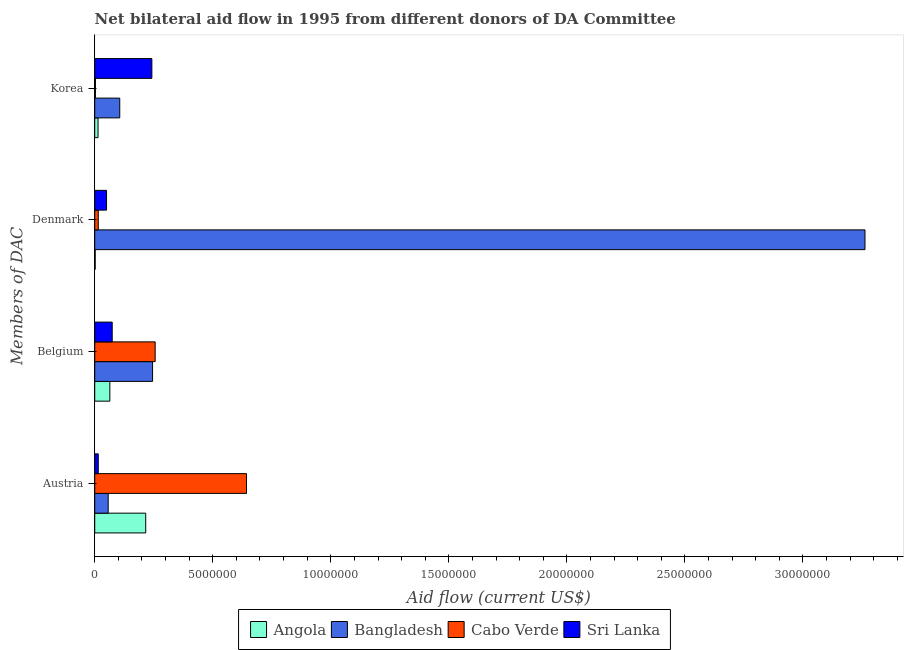How many different coloured bars are there?
Your answer should be compact. 4. Are the number of bars per tick equal to the number of legend labels?
Offer a terse response. Yes. Are the number of bars on each tick of the Y-axis equal?
Your answer should be compact. Yes. How many bars are there on the 1st tick from the bottom?
Make the answer very short. 4. What is the amount of aid given by korea in Bangladesh?
Provide a succinct answer. 1.06e+06. Across all countries, what is the maximum amount of aid given by denmark?
Your answer should be very brief. 3.26e+07. Across all countries, what is the minimum amount of aid given by austria?
Provide a succinct answer. 1.50e+05. In which country was the amount of aid given by korea maximum?
Provide a succinct answer. Sri Lanka. In which country was the amount of aid given by denmark minimum?
Your response must be concise. Angola. What is the total amount of aid given by belgium in the graph?
Give a very brief answer. 6.39e+06. What is the difference between the amount of aid given by belgium in Cabo Verde and that in Bangladesh?
Offer a terse response. 1.10e+05. What is the difference between the amount of aid given by korea in Sri Lanka and the amount of aid given by belgium in Cabo Verde?
Your response must be concise. -1.40e+05. What is the average amount of aid given by belgium per country?
Offer a terse response. 1.60e+06. What is the difference between the amount of aid given by korea and amount of aid given by austria in Angola?
Your answer should be compact. -2.02e+06. What is the ratio of the amount of aid given by denmark in Bangladesh to that in Angola?
Your response must be concise. 1631.5. Is the difference between the amount of aid given by austria in Cabo Verde and Bangladesh greater than the difference between the amount of aid given by denmark in Cabo Verde and Bangladesh?
Offer a terse response. Yes. What is the difference between the highest and the second highest amount of aid given by belgium?
Offer a terse response. 1.10e+05. What is the difference between the highest and the lowest amount of aid given by austria?
Give a very brief answer. 6.28e+06. In how many countries, is the amount of aid given by korea greater than the average amount of aid given by korea taken over all countries?
Offer a terse response. 2. Is the sum of the amount of aid given by austria in Angola and Sri Lanka greater than the maximum amount of aid given by korea across all countries?
Offer a very short reply. No. What does the 2nd bar from the bottom in Austria represents?
Give a very brief answer. Bangladesh. How many bars are there?
Your answer should be compact. 16. Are all the bars in the graph horizontal?
Make the answer very short. Yes. How many countries are there in the graph?
Offer a terse response. 4. Does the graph contain grids?
Your answer should be compact. No. Where does the legend appear in the graph?
Offer a terse response. Bottom center. What is the title of the graph?
Offer a terse response. Net bilateral aid flow in 1995 from different donors of DA Committee. Does "Vietnam" appear as one of the legend labels in the graph?
Offer a very short reply. No. What is the label or title of the Y-axis?
Offer a terse response. Members of DAC. What is the Aid flow (current US$) in Angola in Austria?
Your answer should be compact. 2.16e+06. What is the Aid flow (current US$) in Bangladesh in Austria?
Provide a short and direct response. 5.70e+05. What is the Aid flow (current US$) of Cabo Verde in Austria?
Provide a short and direct response. 6.43e+06. What is the Aid flow (current US$) of Sri Lanka in Austria?
Keep it short and to the point. 1.50e+05. What is the Aid flow (current US$) of Angola in Belgium?
Your answer should be very brief. 6.40e+05. What is the Aid flow (current US$) in Bangladesh in Belgium?
Make the answer very short. 2.45e+06. What is the Aid flow (current US$) of Cabo Verde in Belgium?
Give a very brief answer. 2.56e+06. What is the Aid flow (current US$) of Sri Lanka in Belgium?
Provide a short and direct response. 7.40e+05. What is the Aid flow (current US$) of Bangladesh in Denmark?
Your answer should be compact. 3.26e+07. What is the Aid flow (current US$) in Sri Lanka in Denmark?
Your answer should be very brief. 5.00e+05. What is the Aid flow (current US$) in Bangladesh in Korea?
Offer a very short reply. 1.06e+06. What is the Aid flow (current US$) of Cabo Verde in Korea?
Offer a terse response. 3.00e+04. What is the Aid flow (current US$) in Sri Lanka in Korea?
Your answer should be very brief. 2.42e+06. Across all Members of DAC, what is the maximum Aid flow (current US$) in Angola?
Your response must be concise. 2.16e+06. Across all Members of DAC, what is the maximum Aid flow (current US$) of Bangladesh?
Your answer should be very brief. 3.26e+07. Across all Members of DAC, what is the maximum Aid flow (current US$) of Cabo Verde?
Your answer should be very brief. 6.43e+06. Across all Members of DAC, what is the maximum Aid flow (current US$) in Sri Lanka?
Your answer should be compact. 2.42e+06. Across all Members of DAC, what is the minimum Aid flow (current US$) of Angola?
Provide a short and direct response. 2.00e+04. Across all Members of DAC, what is the minimum Aid flow (current US$) in Bangladesh?
Your answer should be compact. 5.70e+05. Across all Members of DAC, what is the minimum Aid flow (current US$) of Cabo Verde?
Provide a short and direct response. 3.00e+04. What is the total Aid flow (current US$) in Angola in the graph?
Provide a succinct answer. 2.96e+06. What is the total Aid flow (current US$) of Bangladesh in the graph?
Offer a terse response. 3.67e+07. What is the total Aid flow (current US$) in Cabo Verde in the graph?
Make the answer very short. 9.17e+06. What is the total Aid flow (current US$) in Sri Lanka in the graph?
Your answer should be very brief. 3.81e+06. What is the difference between the Aid flow (current US$) in Angola in Austria and that in Belgium?
Give a very brief answer. 1.52e+06. What is the difference between the Aid flow (current US$) in Bangladesh in Austria and that in Belgium?
Your answer should be very brief. -1.88e+06. What is the difference between the Aid flow (current US$) in Cabo Verde in Austria and that in Belgium?
Your answer should be compact. 3.87e+06. What is the difference between the Aid flow (current US$) of Sri Lanka in Austria and that in Belgium?
Provide a succinct answer. -5.90e+05. What is the difference between the Aid flow (current US$) in Angola in Austria and that in Denmark?
Your answer should be compact. 2.14e+06. What is the difference between the Aid flow (current US$) in Bangladesh in Austria and that in Denmark?
Give a very brief answer. -3.21e+07. What is the difference between the Aid flow (current US$) in Cabo Verde in Austria and that in Denmark?
Your answer should be compact. 6.28e+06. What is the difference between the Aid flow (current US$) of Sri Lanka in Austria and that in Denmark?
Your answer should be very brief. -3.50e+05. What is the difference between the Aid flow (current US$) of Angola in Austria and that in Korea?
Your answer should be very brief. 2.02e+06. What is the difference between the Aid flow (current US$) in Bangladesh in Austria and that in Korea?
Your answer should be very brief. -4.90e+05. What is the difference between the Aid flow (current US$) of Cabo Verde in Austria and that in Korea?
Your answer should be very brief. 6.40e+06. What is the difference between the Aid flow (current US$) of Sri Lanka in Austria and that in Korea?
Give a very brief answer. -2.27e+06. What is the difference between the Aid flow (current US$) of Angola in Belgium and that in Denmark?
Offer a very short reply. 6.20e+05. What is the difference between the Aid flow (current US$) of Bangladesh in Belgium and that in Denmark?
Offer a very short reply. -3.02e+07. What is the difference between the Aid flow (current US$) in Cabo Verde in Belgium and that in Denmark?
Give a very brief answer. 2.41e+06. What is the difference between the Aid flow (current US$) of Sri Lanka in Belgium and that in Denmark?
Your answer should be very brief. 2.40e+05. What is the difference between the Aid flow (current US$) in Angola in Belgium and that in Korea?
Your response must be concise. 5.00e+05. What is the difference between the Aid flow (current US$) in Bangladesh in Belgium and that in Korea?
Make the answer very short. 1.39e+06. What is the difference between the Aid flow (current US$) of Cabo Verde in Belgium and that in Korea?
Give a very brief answer. 2.53e+06. What is the difference between the Aid flow (current US$) of Sri Lanka in Belgium and that in Korea?
Your answer should be compact. -1.68e+06. What is the difference between the Aid flow (current US$) of Angola in Denmark and that in Korea?
Your answer should be compact. -1.20e+05. What is the difference between the Aid flow (current US$) in Bangladesh in Denmark and that in Korea?
Offer a terse response. 3.16e+07. What is the difference between the Aid flow (current US$) in Cabo Verde in Denmark and that in Korea?
Provide a short and direct response. 1.20e+05. What is the difference between the Aid flow (current US$) of Sri Lanka in Denmark and that in Korea?
Ensure brevity in your answer.  -1.92e+06. What is the difference between the Aid flow (current US$) in Angola in Austria and the Aid flow (current US$) in Bangladesh in Belgium?
Provide a short and direct response. -2.90e+05. What is the difference between the Aid flow (current US$) of Angola in Austria and the Aid flow (current US$) of Cabo Verde in Belgium?
Provide a short and direct response. -4.00e+05. What is the difference between the Aid flow (current US$) in Angola in Austria and the Aid flow (current US$) in Sri Lanka in Belgium?
Provide a succinct answer. 1.42e+06. What is the difference between the Aid flow (current US$) in Bangladesh in Austria and the Aid flow (current US$) in Cabo Verde in Belgium?
Ensure brevity in your answer.  -1.99e+06. What is the difference between the Aid flow (current US$) in Bangladesh in Austria and the Aid flow (current US$) in Sri Lanka in Belgium?
Keep it short and to the point. -1.70e+05. What is the difference between the Aid flow (current US$) of Cabo Verde in Austria and the Aid flow (current US$) of Sri Lanka in Belgium?
Give a very brief answer. 5.69e+06. What is the difference between the Aid flow (current US$) of Angola in Austria and the Aid flow (current US$) of Bangladesh in Denmark?
Your answer should be very brief. -3.05e+07. What is the difference between the Aid flow (current US$) of Angola in Austria and the Aid flow (current US$) of Cabo Verde in Denmark?
Keep it short and to the point. 2.01e+06. What is the difference between the Aid flow (current US$) in Angola in Austria and the Aid flow (current US$) in Sri Lanka in Denmark?
Provide a succinct answer. 1.66e+06. What is the difference between the Aid flow (current US$) of Bangladesh in Austria and the Aid flow (current US$) of Cabo Verde in Denmark?
Keep it short and to the point. 4.20e+05. What is the difference between the Aid flow (current US$) of Bangladesh in Austria and the Aid flow (current US$) of Sri Lanka in Denmark?
Your answer should be very brief. 7.00e+04. What is the difference between the Aid flow (current US$) in Cabo Verde in Austria and the Aid flow (current US$) in Sri Lanka in Denmark?
Your answer should be very brief. 5.93e+06. What is the difference between the Aid flow (current US$) in Angola in Austria and the Aid flow (current US$) in Bangladesh in Korea?
Offer a terse response. 1.10e+06. What is the difference between the Aid flow (current US$) of Angola in Austria and the Aid flow (current US$) of Cabo Verde in Korea?
Provide a short and direct response. 2.13e+06. What is the difference between the Aid flow (current US$) of Bangladesh in Austria and the Aid flow (current US$) of Cabo Verde in Korea?
Offer a very short reply. 5.40e+05. What is the difference between the Aid flow (current US$) in Bangladesh in Austria and the Aid flow (current US$) in Sri Lanka in Korea?
Keep it short and to the point. -1.85e+06. What is the difference between the Aid flow (current US$) of Cabo Verde in Austria and the Aid flow (current US$) of Sri Lanka in Korea?
Provide a short and direct response. 4.01e+06. What is the difference between the Aid flow (current US$) in Angola in Belgium and the Aid flow (current US$) in Bangladesh in Denmark?
Offer a terse response. -3.20e+07. What is the difference between the Aid flow (current US$) of Angola in Belgium and the Aid flow (current US$) of Cabo Verde in Denmark?
Ensure brevity in your answer.  4.90e+05. What is the difference between the Aid flow (current US$) in Bangladesh in Belgium and the Aid flow (current US$) in Cabo Verde in Denmark?
Provide a succinct answer. 2.30e+06. What is the difference between the Aid flow (current US$) in Bangladesh in Belgium and the Aid flow (current US$) in Sri Lanka in Denmark?
Provide a succinct answer. 1.95e+06. What is the difference between the Aid flow (current US$) of Cabo Verde in Belgium and the Aid flow (current US$) of Sri Lanka in Denmark?
Give a very brief answer. 2.06e+06. What is the difference between the Aid flow (current US$) of Angola in Belgium and the Aid flow (current US$) of Bangladesh in Korea?
Provide a succinct answer. -4.20e+05. What is the difference between the Aid flow (current US$) of Angola in Belgium and the Aid flow (current US$) of Sri Lanka in Korea?
Your response must be concise. -1.78e+06. What is the difference between the Aid flow (current US$) in Bangladesh in Belgium and the Aid flow (current US$) in Cabo Verde in Korea?
Provide a short and direct response. 2.42e+06. What is the difference between the Aid flow (current US$) of Bangladesh in Belgium and the Aid flow (current US$) of Sri Lanka in Korea?
Provide a succinct answer. 3.00e+04. What is the difference between the Aid flow (current US$) of Angola in Denmark and the Aid flow (current US$) of Bangladesh in Korea?
Your answer should be compact. -1.04e+06. What is the difference between the Aid flow (current US$) in Angola in Denmark and the Aid flow (current US$) in Cabo Verde in Korea?
Ensure brevity in your answer.  -10000. What is the difference between the Aid flow (current US$) in Angola in Denmark and the Aid flow (current US$) in Sri Lanka in Korea?
Provide a succinct answer. -2.40e+06. What is the difference between the Aid flow (current US$) in Bangladesh in Denmark and the Aid flow (current US$) in Cabo Verde in Korea?
Your answer should be very brief. 3.26e+07. What is the difference between the Aid flow (current US$) of Bangladesh in Denmark and the Aid flow (current US$) of Sri Lanka in Korea?
Provide a succinct answer. 3.02e+07. What is the difference between the Aid flow (current US$) in Cabo Verde in Denmark and the Aid flow (current US$) in Sri Lanka in Korea?
Offer a terse response. -2.27e+06. What is the average Aid flow (current US$) in Angola per Members of DAC?
Ensure brevity in your answer.  7.40e+05. What is the average Aid flow (current US$) in Bangladesh per Members of DAC?
Provide a succinct answer. 9.18e+06. What is the average Aid flow (current US$) of Cabo Verde per Members of DAC?
Offer a very short reply. 2.29e+06. What is the average Aid flow (current US$) in Sri Lanka per Members of DAC?
Your answer should be very brief. 9.52e+05. What is the difference between the Aid flow (current US$) in Angola and Aid flow (current US$) in Bangladesh in Austria?
Your answer should be compact. 1.59e+06. What is the difference between the Aid flow (current US$) in Angola and Aid flow (current US$) in Cabo Verde in Austria?
Keep it short and to the point. -4.27e+06. What is the difference between the Aid flow (current US$) of Angola and Aid flow (current US$) of Sri Lanka in Austria?
Your answer should be very brief. 2.01e+06. What is the difference between the Aid flow (current US$) of Bangladesh and Aid flow (current US$) of Cabo Verde in Austria?
Your answer should be compact. -5.86e+06. What is the difference between the Aid flow (current US$) in Cabo Verde and Aid flow (current US$) in Sri Lanka in Austria?
Keep it short and to the point. 6.28e+06. What is the difference between the Aid flow (current US$) in Angola and Aid flow (current US$) in Bangladesh in Belgium?
Your answer should be very brief. -1.81e+06. What is the difference between the Aid flow (current US$) in Angola and Aid flow (current US$) in Cabo Verde in Belgium?
Make the answer very short. -1.92e+06. What is the difference between the Aid flow (current US$) of Angola and Aid flow (current US$) of Sri Lanka in Belgium?
Your answer should be compact. -1.00e+05. What is the difference between the Aid flow (current US$) of Bangladesh and Aid flow (current US$) of Cabo Verde in Belgium?
Your answer should be very brief. -1.10e+05. What is the difference between the Aid flow (current US$) in Bangladesh and Aid flow (current US$) in Sri Lanka in Belgium?
Make the answer very short. 1.71e+06. What is the difference between the Aid flow (current US$) of Cabo Verde and Aid flow (current US$) of Sri Lanka in Belgium?
Your answer should be very brief. 1.82e+06. What is the difference between the Aid flow (current US$) in Angola and Aid flow (current US$) in Bangladesh in Denmark?
Provide a succinct answer. -3.26e+07. What is the difference between the Aid flow (current US$) of Angola and Aid flow (current US$) of Sri Lanka in Denmark?
Make the answer very short. -4.80e+05. What is the difference between the Aid flow (current US$) of Bangladesh and Aid flow (current US$) of Cabo Verde in Denmark?
Ensure brevity in your answer.  3.25e+07. What is the difference between the Aid flow (current US$) in Bangladesh and Aid flow (current US$) in Sri Lanka in Denmark?
Provide a succinct answer. 3.21e+07. What is the difference between the Aid flow (current US$) of Cabo Verde and Aid flow (current US$) of Sri Lanka in Denmark?
Make the answer very short. -3.50e+05. What is the difference between the Aid flow (current US$) in Angola and Aid flow (current US$) in Bangladesh in Korea?
Your answer should be compact. -9.20e+05. What is the difference between the Aid flow (current US$) of Angola and Aid flow (current US$) of Cabo Verde in Korea?
Offer a terse response. 1.10e+05. What is the difference between the Aid flow (current US$) in Angola and Aid flow (current US$) in Sri Lanka in Korea?
Keep it short and to the point. -2.28e+06. What is the difference between the Aid flow (current US$) of Bangladesh and Aid flow (current US$) of Cabo Verde in Korea?
Offer a terse response. 1.03e+06. What is the difference between the Aid flow (current US$) in Bangladesh and Aid flow (current US$) in Sri Lanka in Korea?
Offer a very short reply. -1.36e+06. What is the difference between the Aid flow (current US$) in Cabo Verde and Aid flow (current US$) in Sri Lanka in Korea?
Your answer should be very brief. -2.39e+06. What is the ratio of the Aid flow (current US$) in Angola in Austria to that in Belgium?
Make the answer very short. 3.38. What is the ratio of the Aid flow (current US$) of Bangladesh in Austria to that in Belgium?
Keep it short and to the point. 0.23. What is the ratio of the Aid flow (current US$) in Cabo Verde in Austria to that in Belgium?
Offer a terse response. 2.51. What is the ratio of the Aid flow (current US$) in Sri Lanka in Austria to that in Belgium?
Your answer should be very brief. 0.2. What is the ratio of the Aid flow (current US$) of Angola in Austria to that in Denmark?
Keep it short and to the point. 108. What is the ratio of the Aid flow (current US$) in Bangladesh in Austria to that in Denmark?
Give a very brief answer. 0.02. What is the ratio of the Aid flow (current US$) in Cabo Verde in Austria to that in Denmark?
Give a very brief answer. 42.87. What is the ratio of the Aid flow (current US$) of Angola in Austria to that in Korea?
Offer a terse response. 15.43. What is the ratio of the Aid flow (current US$) of Bangladesh in Austria to that in Korea?
Ensure brevity in your answer.  0.54. What is the ratio of the Aid flow (current US$) of Cabo Verde in Austria to that in Korea?
Give a very brief answer. 214.33. What is the ratio of the Aid flow (current US$) in Sri Lanka in Austria to that in Korea?
Offer a terse response. 0.06. What is the ratio of the Aid flow (current US$) in Angola in Belgium to that in Denmark?
Offer a very short reply. 32. What is the ratio of the Aid flow (current US$) of Bangladesh in Belgium to that in Denmark?
Your answer should be compact. 0.08. What is the ratio of the Aid flow (current US$) of Cabo Verde in Belgium to that in Denmark?
Your answer should be very brief. 17.07. What is the ratio of the Aid flow (current US$) of Sri Lanka in Belgium to that in Denmark?
Make the answer very short. 1.48. What is the ratio of the Aid flow (current US$) of Angola in Belgium to that in Korea?
Your response must be concise. 4.57. What is the ratio of the Aid flow (current US$) of Bangladesh in Belgium to that in Korea?
Keep it short and to the point. 2.31. What is the ratio of the Aid flow (current US$) of Cabo Verde in Belgium to that in Korea?
Your answer should be very brief. 85.33. What is the ratio of the Aid flow (current US$) in Sri Lanka in Belgium to that in Korea?
Provide a succinct answer. 0.31. What is the ratio of the Aid flow (current US$) in Angola in Denmark to that in Korea?
Ensure brevity in your answer.  0.14. What is the ratio of the Aid flow (current US$) of Bangladesh in Denmark to that in Korea?
Offer a very short reply. 30.78. What is the ratio of the Aid flow (current US$) of Sri Lanka in Denmark to that in Korea?
Provide a succinct answer. 0.21. What is the difference between the highest and the second highest Aid flow (current US$) of Angola?
Keep it short and to the point. 1.52e+06. What is the difference between the highest and the second highest Aid flow (current US$) in Bangladesh?
Ensure brevity in your answer.  3.02e+07. What is the difference between the highest and the second highest Aid flow (current US$) of Cabo Verde?
Your response must be concise. 3.87e+06. What is the difference between the highest and the second highest Aid flow (current US$) of Sri Lanka?
Your answer should be compact. 1.68e+06. What is the difference between the highest and the lowest Aid flow (current US$) in Angola?
Provide a short and direct response. 2.14e+06. What is the difference between the highest and the lowest Aid flow (current US$) in Bangladesh?
Make the answer very short. 3.21e+07. What is the difference between the highest and the lowest Aid flow (current US$) of Cabo Verde?
Your answer should be compact. 6.40e+06. What is the difference between the highest and the lowest Aid flow (current US$) of Sri Lanka?
Provide a short and direct response. 2.27e+06. 